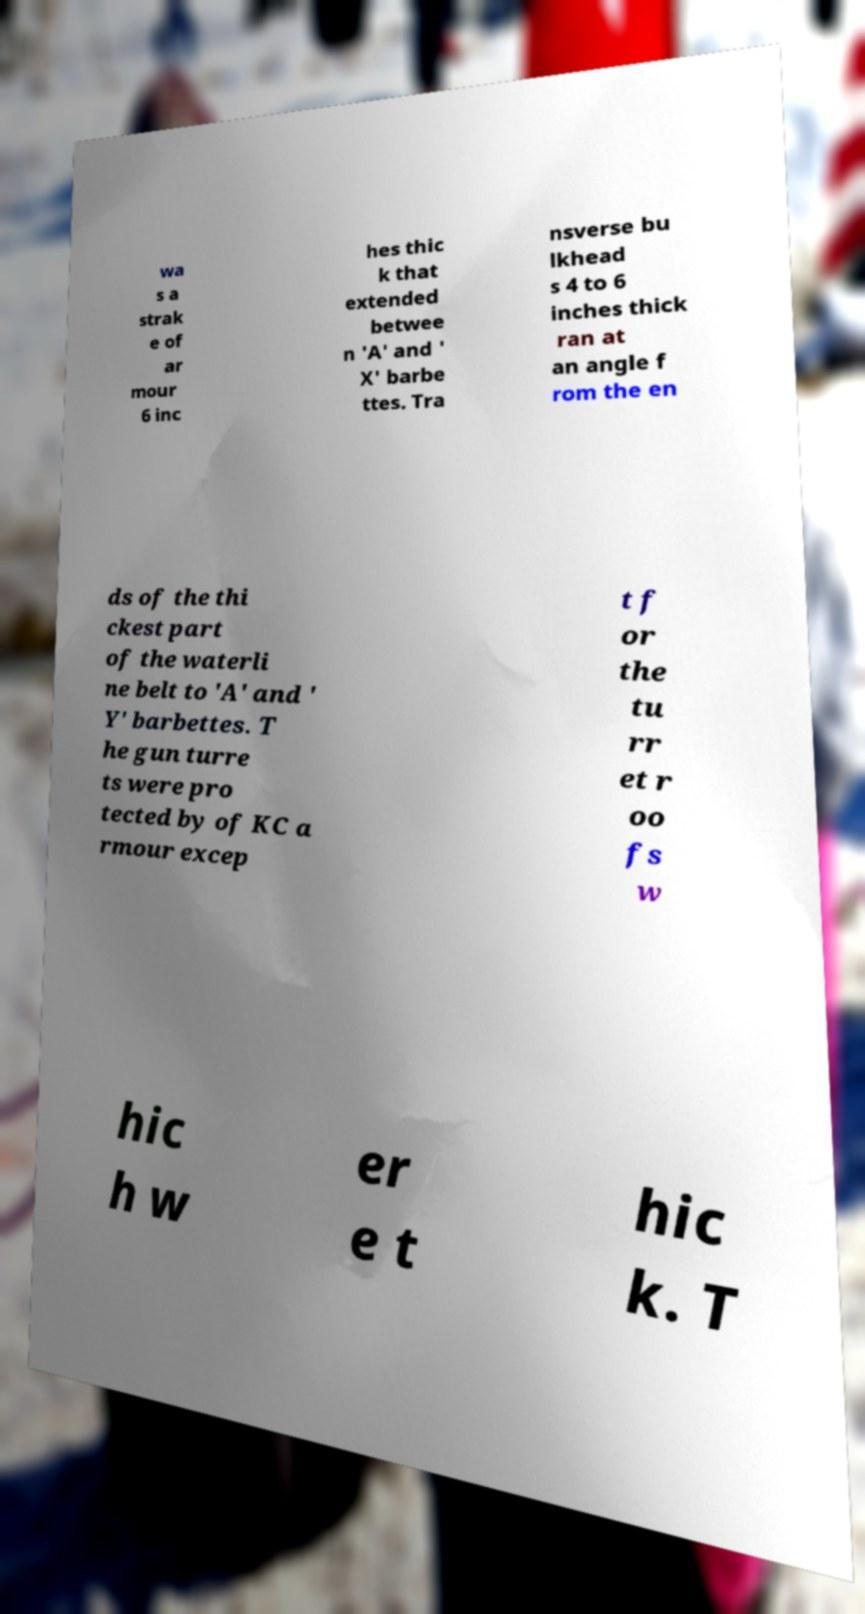What messages or text are displayed in this image? I need them in a readable, typed format. wa s a strak e of ar mour 6 inc hes thic k that extended betwee n 'A' and ' X' barbe ttes. Tra nsverse bu lkhead s 4 to 6 inches thick ran at an angle f rom the en ds of the thi ckest part of the waterli ne belt to 'A' and ' Y' barbettes. T he gun turre ts were pro tected by of KC a rmour excep t f or the tu rr et r oo fs w hic h w er e t hic k. T 